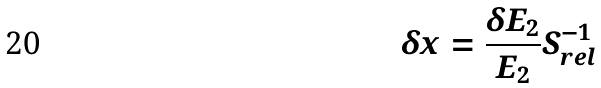<formula> <loc_0><loc_0><loc_500><loc_500>\delta x = \frac { \delta E _ { 2 } } { E _ { 2 } } S _ { r e l } ^ { - 1 }</formula> 